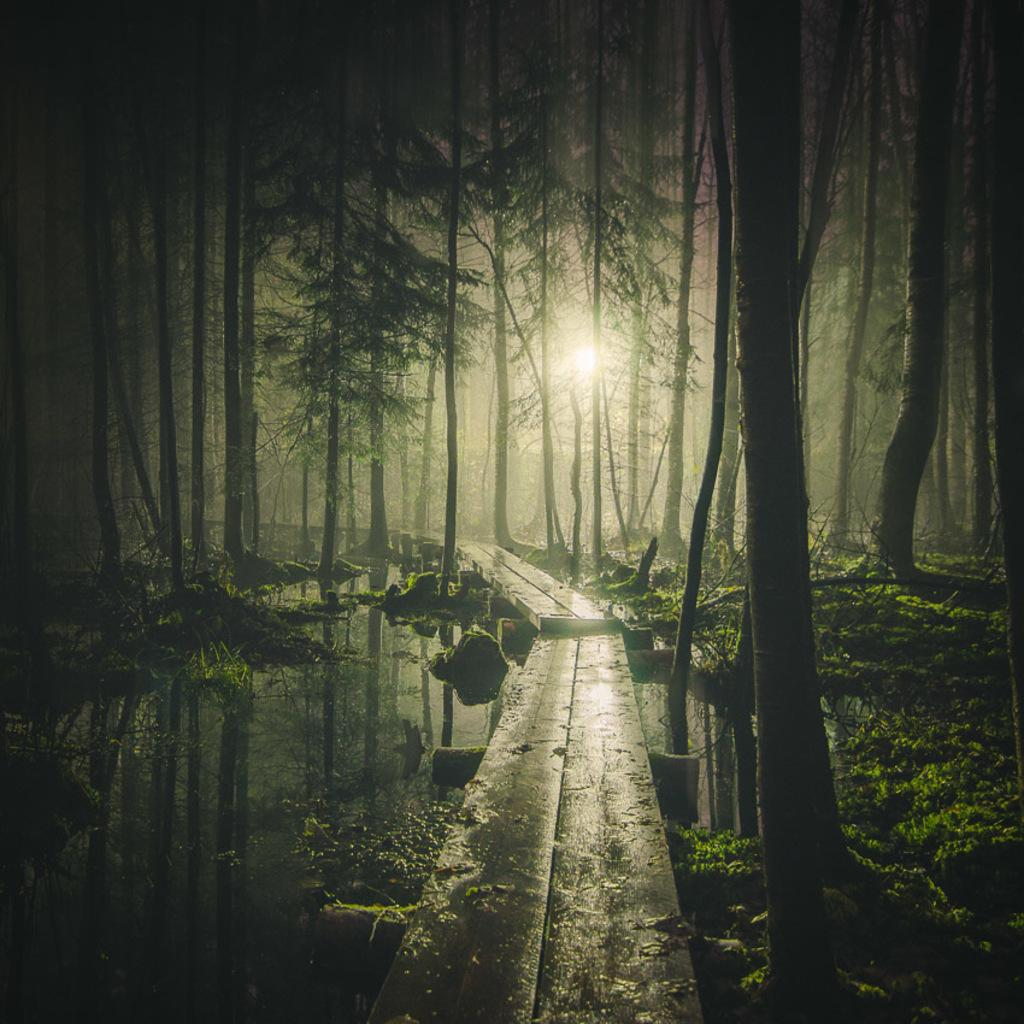Where was the image taken? The image is clicked outside the city. What can be seen in the center of the image? There is a path in the center of the image. What natural feature is visible in the image? There is a water body visible in the image. What type of vegetation is present in the image? Some plants are present in the image. What is visible in the background of the image? There is a sky, trees, and a light visible in the background of the image. How many dogs are playing with the grass in the image? There are no dogs or grass present in the image. Can you describe the type of kiss the couple is sharing in the image? There is no couple or kiss present in the image. 